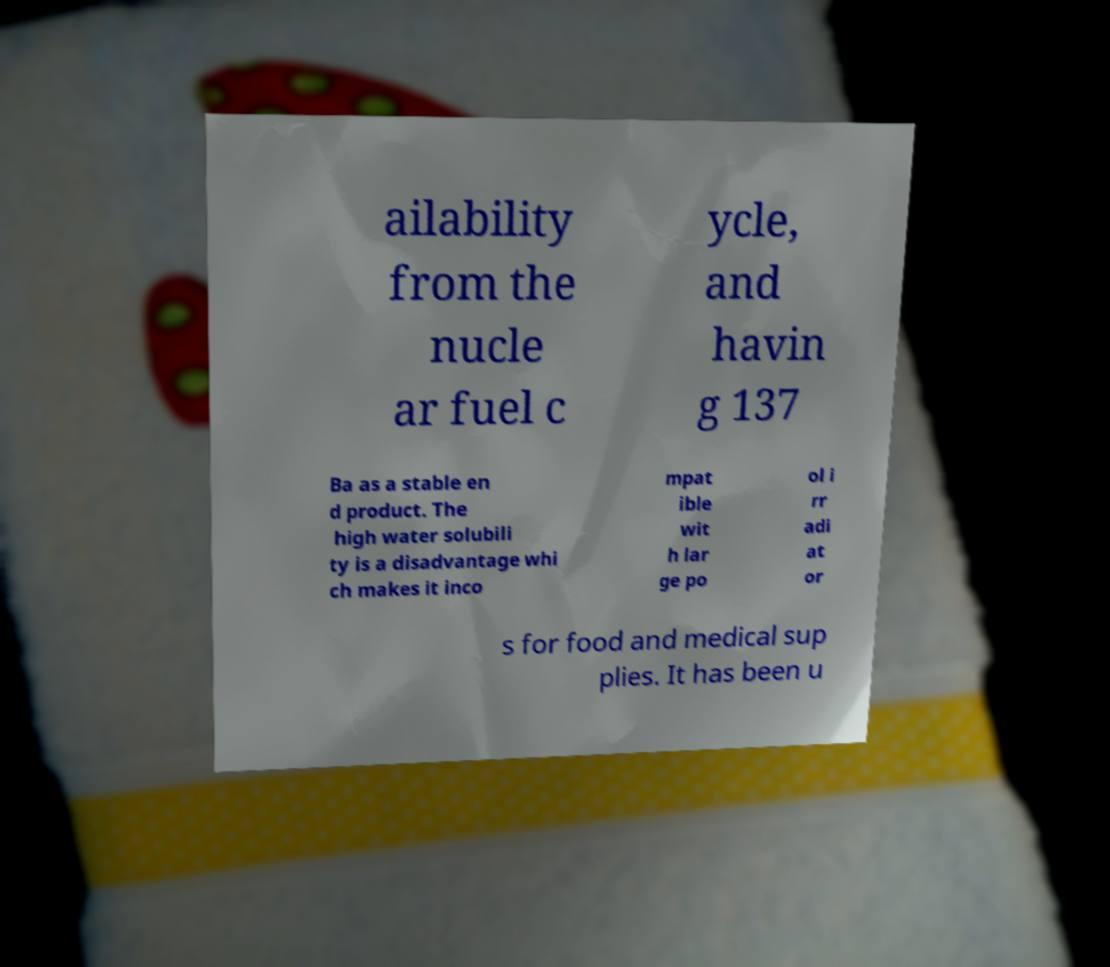Can you accurately transcribe the text from the provided image for me? ailability from the nucle ar fuel c ycle, and havin g 137 Ba as a stable en d product. The high water solubili ty is a disadvantage whi ch makes it inco mpat ible wit h lar ge po ol i rr adi at or s for food and medical sup plies. It has been u 